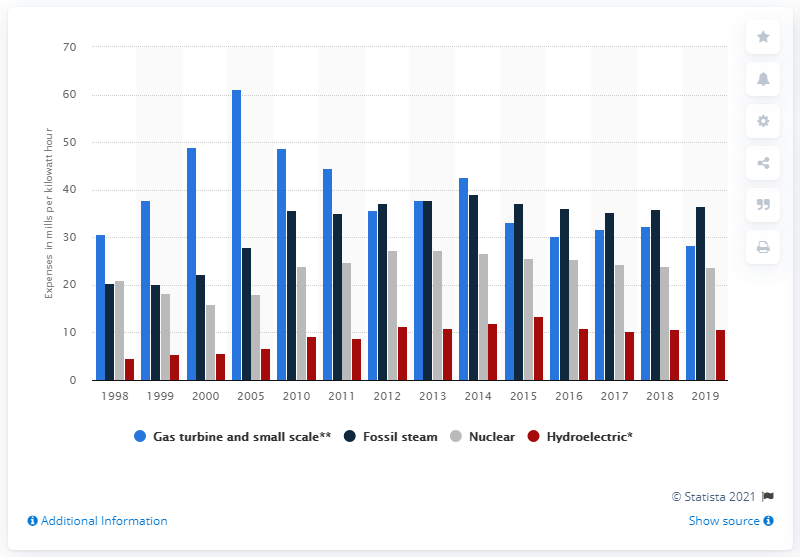Specify some key components in this picture. The operating expenses for nuclear power plants run by investor-owned electric companies were 28.33 mills per kilowatt hour. The amount of mills per kilowatt hour for hydroelectric power plants was 10.8. 